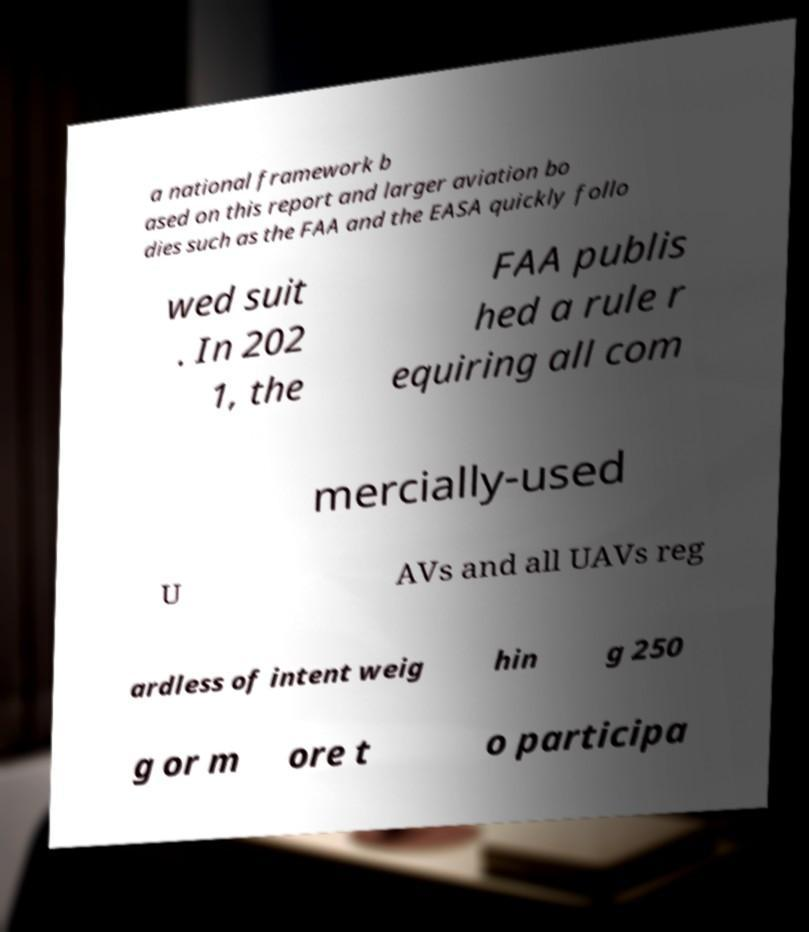Please read and relay the text visible in this image. What does it say? a national framework b ased on this report and larger aviation bo dies such as the FAA and the EASA quickly follo wed suit . In 202 1, the FAA publis hed a rule r equiring all com mercially-used U AVs and all UAVs reg ardless of intent weig hin g 250 g or m ore t o participa 